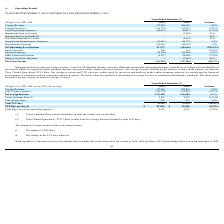From Nordic American Tankers Limited's financial document, What are the respective voyage revenue in 2018 and 2019? The document shows two values: 289,016 and 317,220 (in thousands). From the document: "Voyage Revenue 317,220 289,016 9.8% Voyage Revenue 317,220 289,016 9.8%..." Also, What are the respective voyage expenses in 2018 and 2019? The document shows two values: 165,012 and 141,770 (in thousands). From the document: "Voyage Expenses (141,770) (165,012) (14.1%) Voyage Expenses (141,770) (165,012) (14.1%)..." Also, What are the respective vessel operating expenses in 2018 and 2019? The document shows two values: 80,411 and 66,033 (in thousands). From the document: "Vessel Operating Expenses (66,033) (80,411) (17.9%) Vessel Operating Expenses (66,033) (80,411) (17.9%)..." Also, can you calculate: What is the percentage change in the voyage revenue between 2018 and 2019? To answer this question, I need to perform calculations using the financial data. The calculation is: (317,220-289,016)/289,016 , which equals 9.76 (percentage). This is based on the information: "Voyage Revenue 317,220 289,016 9.8% Voyage Revenue 317,220 289,016 9.8%..." The key data points involved are: 289,016, 317,220. Also, can you calculate: What is the percentage change in the voyage expenses between 2018 and 2019? To answer this question, I need to perform calculations using the financial data. The calculation is: (141,770 - 165,012)/165,012 , which equals -14.09 (percentage). This is based on the information: "Voyage Expenses (141,770) (165,012) (14.1%) Voyage Expenses (141,770) (165,012) (14.1%)..." The key data points involved are: 141,770, 165,012. Also, can you calculate: What is the percentage change in the vessel operating expenses between 2018 and 2019? To answer this question, I need to perform calculations using the financial data. The calculation is: (66,033 - 80,411)/80,411 , which equals -17.88 (percentage). This is based on the information: "Vessel Operating Expenses (66,033) (80,411) (17.9%) Vessel Operating Expenses (66,033) (80,411) (17.9%)..." The key data points involved are: 66,033, 80,411. 